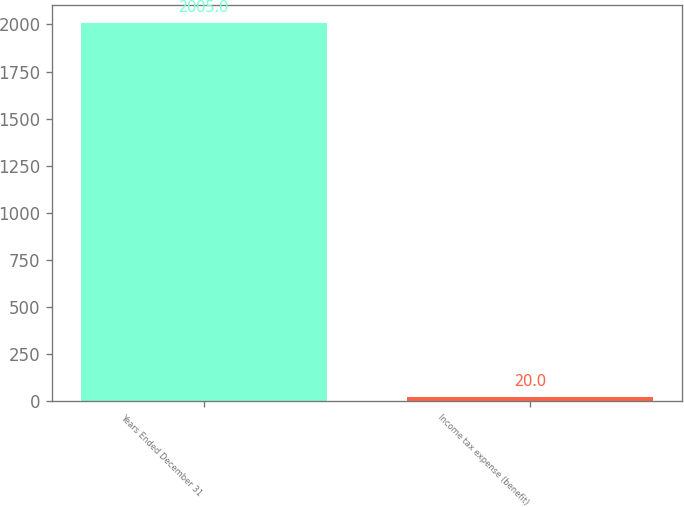Convert chart to OTSL. <chart><loc_0><loc_0><loc_500><loc_500><bar_chart><fcel>Years Ended December 31<fcel>Income tax expense (benefit)<nl><fcel>2005<fcel>20<nl></chart> 